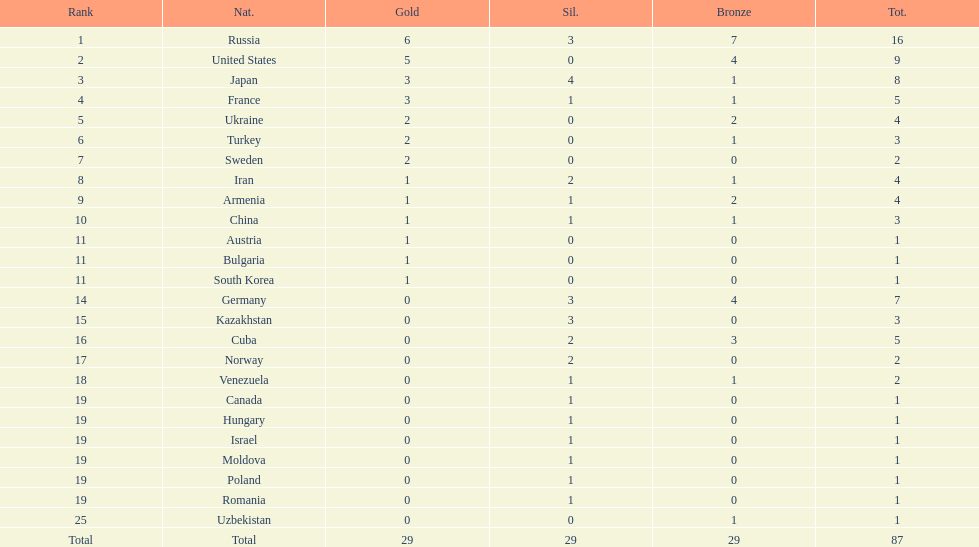Who came directly after turkey in ranking? Sweden. 